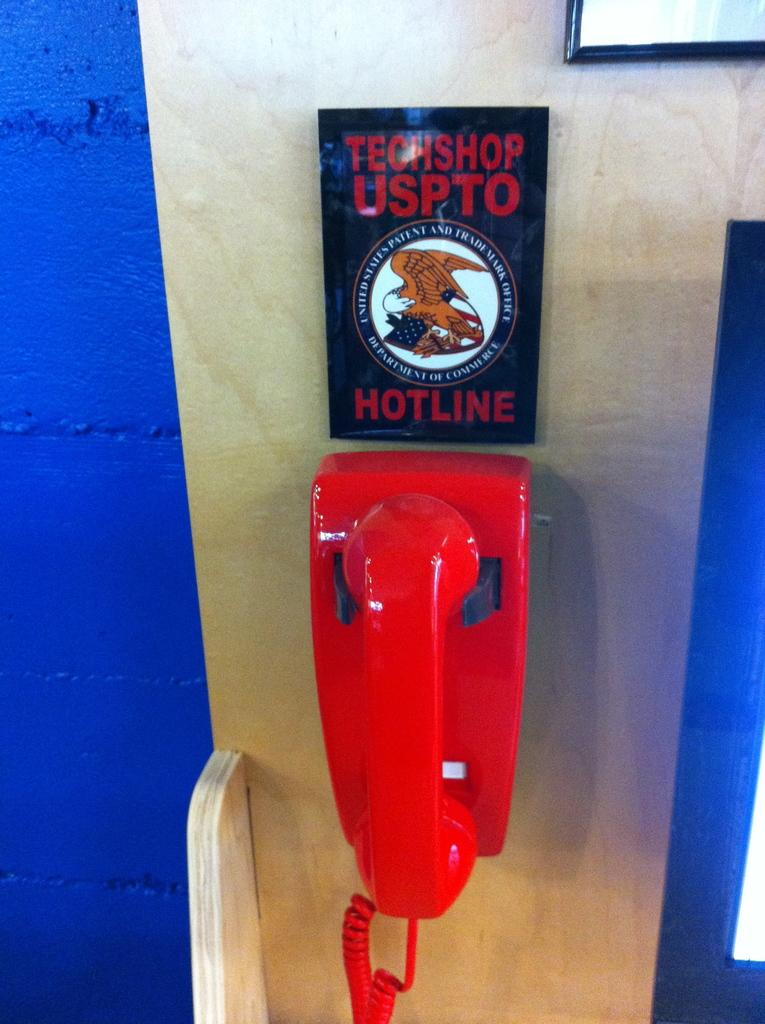<image>
Offer a succinct explanation of the picture presented. A red corded phone halls on the wall overtop of it is something reading Techshop hotline. 